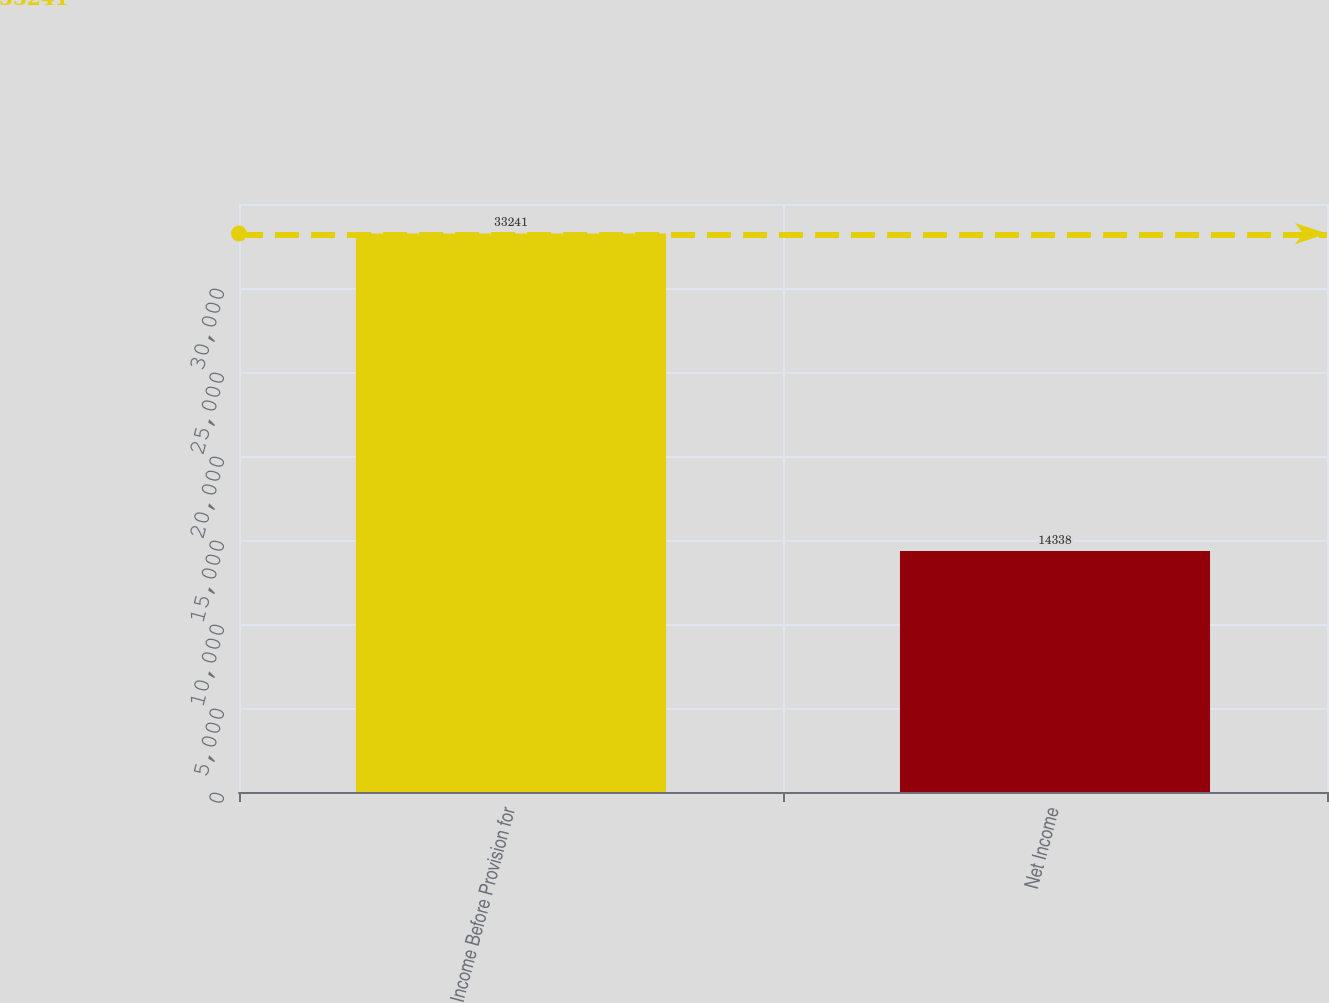Convert chart. <chart><loc_0><loc_0><loc_500><loc_500><bar_chart><fcel>Income Before Provision for<fcel>Net Income<nl><fcel>33241<fcel>14338<nl></chart> 